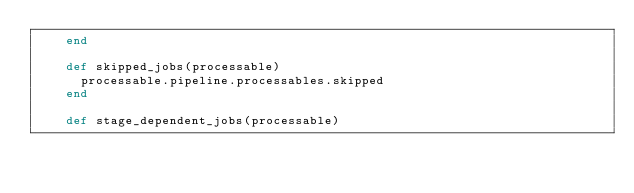<code> <loc_0><loc_0><loc_500><loc_500><_Ruby_>    end

    def skipped_jobs(processable)
      processable.pipeline.processables.skipped
    end

    def stage_dependent_jobs(processable)</code> 